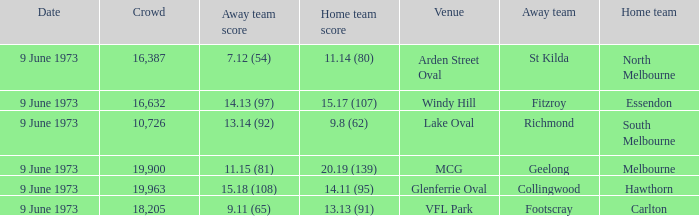Where did Fitzroy play as the away team? Windy Hill. 